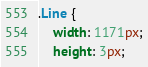Convert code to text. <code><loc_0><loc_0><loc_500><loc_500><_CSS_>.Line {
    width: 1171px;
    height: 3px;</code> 